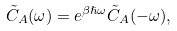<formula> <loc_0><loc_0><loc_500><loc_500>\tilde { C } _ { A } ( \omega ) = e ^ { \beta \hslash \omega } \tilde { C } _ { A } ( - \omega ) ,</formula> 